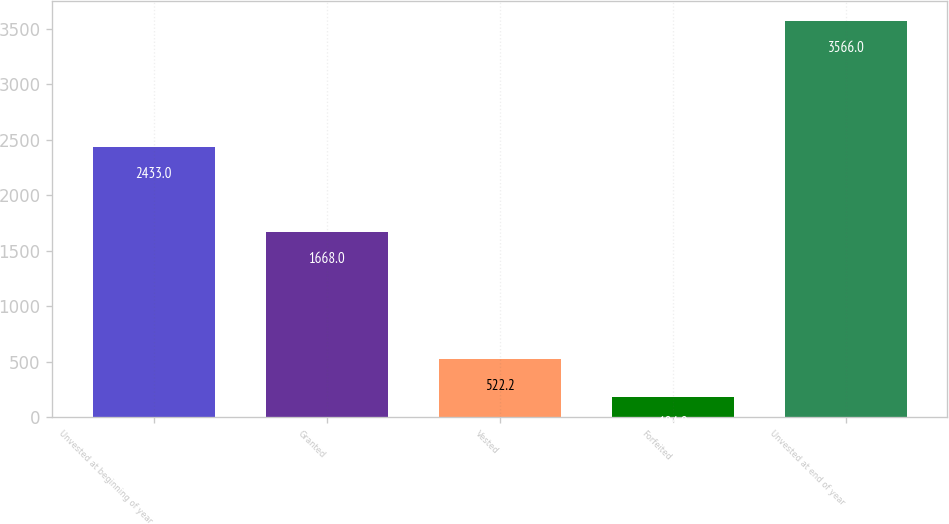Convert chart. <chart><loc_0><loc_0><loc_500><loc_500><bar_chart><fcel>Unvested at beginning of year<fcel>Granted<fcel>Vested<fcel>Forfeited<fcel>Unvested at end of year<nl><fcel>2433<fcel>1668<fcel>522.2<fcel>184<fcel>3566<nl></chart> 